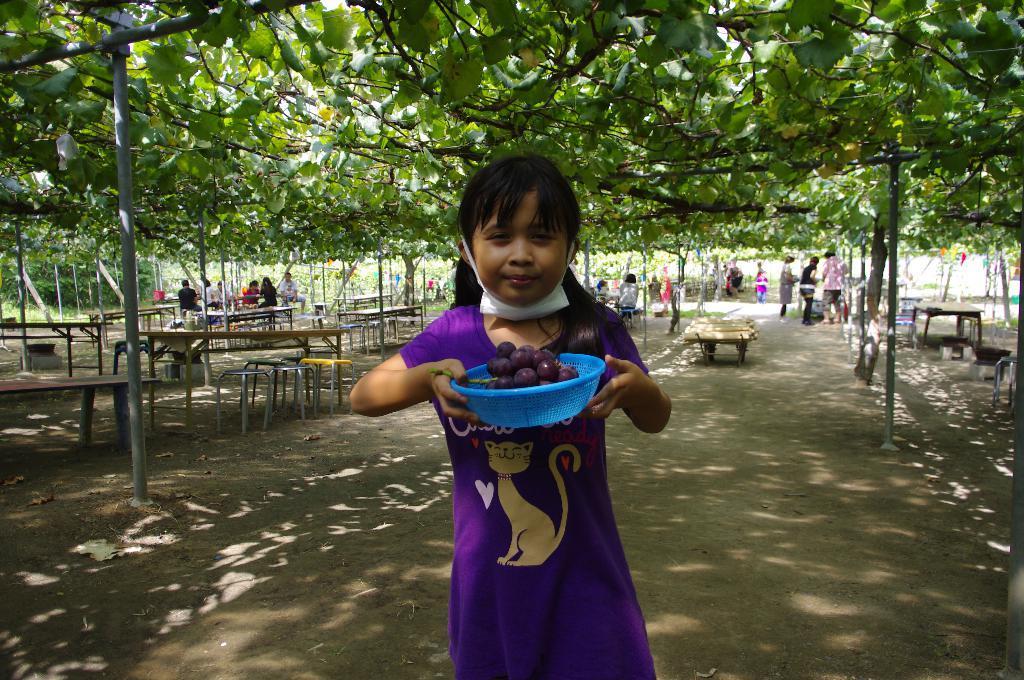How would you summarize this image in a sentence or two? In this image, we can see a grapes garden. There are some persons, tables and stools in the middle of the image. There is a kid at the bottom of the image standing and holding a grapes basket with her hands. 